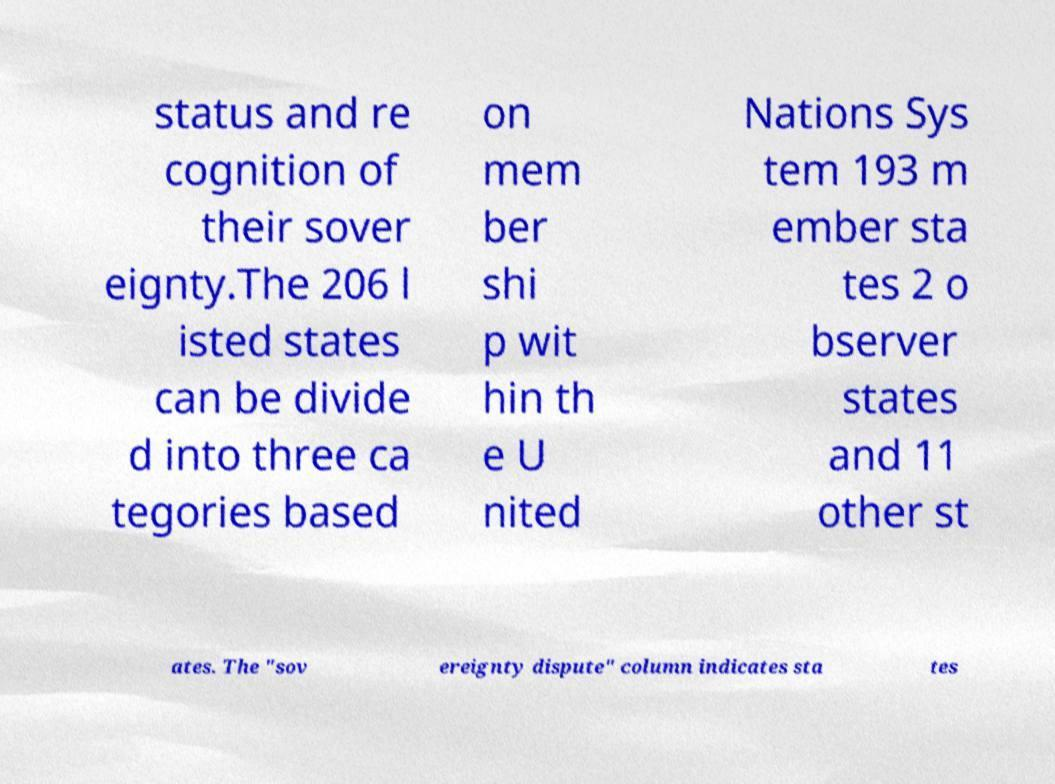Could you assist in decoding the text presented in this image and type it out clearly? status and re cognition of their sover eignty.The 206 l isted states can be divide d into three ca tegories based on mem ber shi p wit hin th e U nited Nations Sys tem 193 m ember sta tes 2 o bserver states and 11 other st ates. The "sov ereignty dispute" column indicates sta tes 